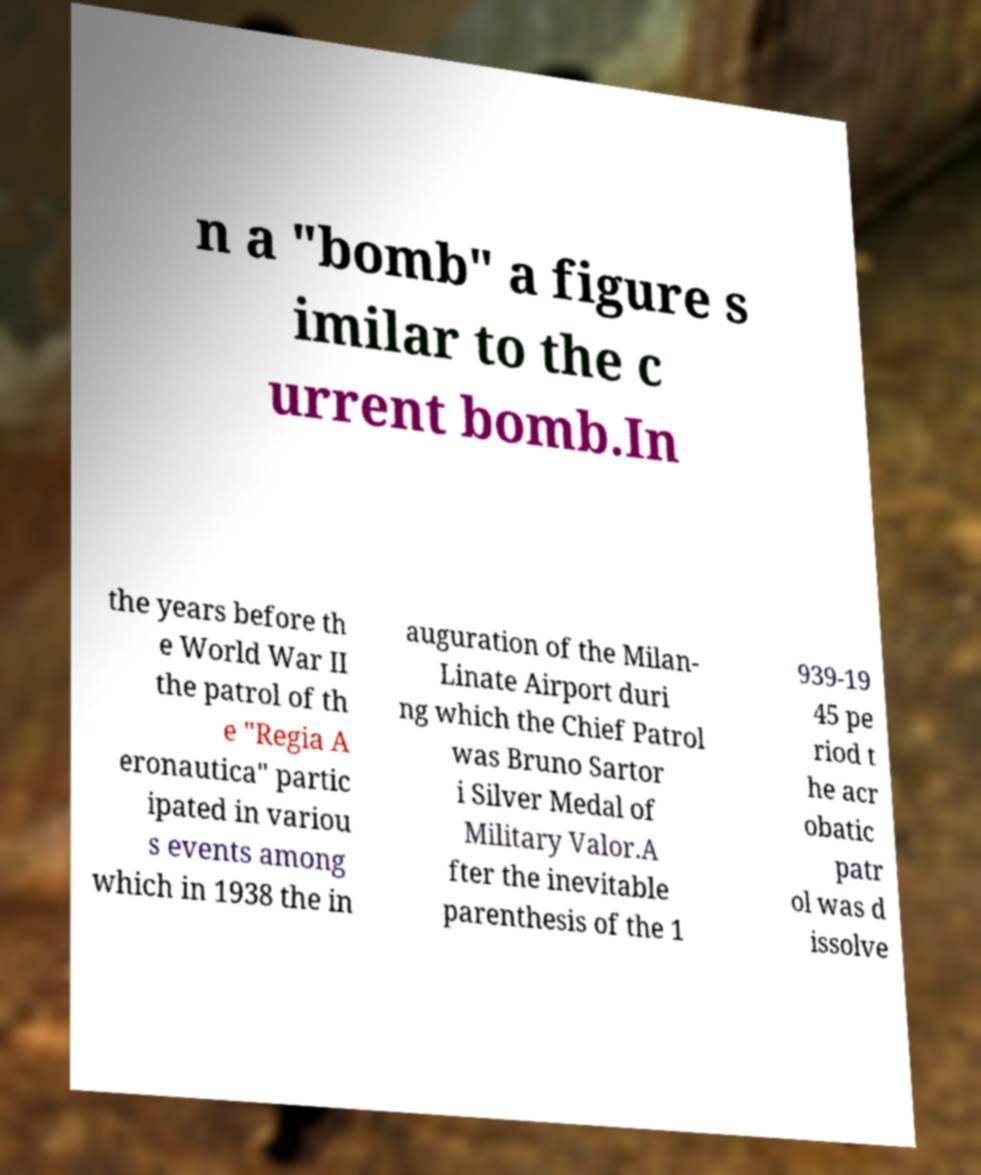What messages or text are displayed in this image? I need them in a readable, typed format. n a "bomb" a figure s imilar to the c urrent bomb.In the years before th e World War II the patrol of th e "Regia A eronautica" partic ipated in variou s events among which in 1938 the in auguration of the Milan- Linate Airport duri ng which the Chief Patrol was Bruno Sartor i Silver Medal of Military Valor.A fter the inevitable parenthesis of the 1 939-19 45 pe riod t he acr obatic patr ol was d issolve 